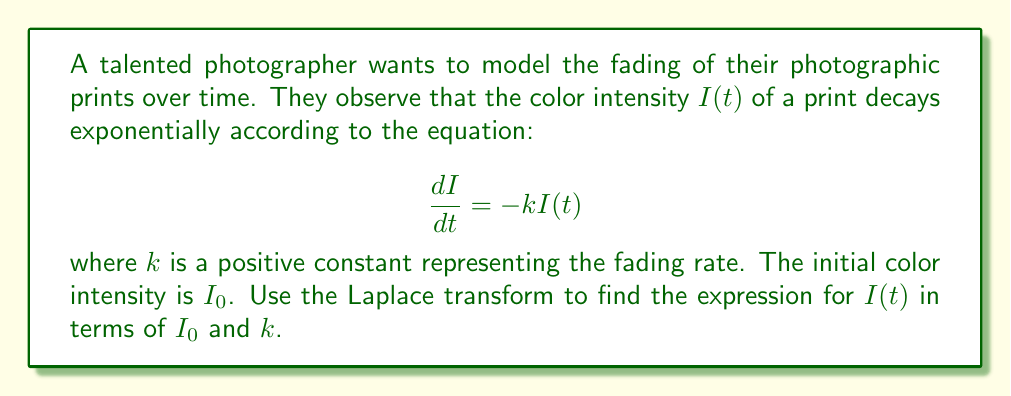Give your solution to this math problem. To solve this problem using Laplace transforms, we'll follow these steps:

1) First, let's take the Laplace transform of both sides of the differential equation:

   $$\mathcal{L}\left\{\frac{dI}{dt}\right\} = \mathcal{L}\{-kI(t)\}$$

2) Using the property of Laplace transform for derivatives:

   $$s\mathcal{L}\{I(t)\} - I(0) = -k\mathcal{L}\{I(t)\}$$

3) Let $\mathcal{L}\{I(t)\} = F(s)$. We know that $I(0) = I_0$. Substituting:

   $$sF(s) - I_0 = -kF(s)$$

4) Rearranging the equation:

   $$sF(s) + kF(s) = I_0$$
   $$(s + k)F(s) = I_0$$

5) Solving for $F(s)$:

   $$F(s) = \frac{I_0}{s + k}$$

6) This is the Laplace transform of $I(t)$. To find $I(t)$, we need to take the inverse Laplace transform:

   $$I(t) = \mathcal{L}^{-1}\left\{\frac{I_0}{s + k}\right\}$$

7) From the table of Laplace transforms, we recognize this as the transform of an exponential function:

   $$I(t) = I_0e^{-kt}$$

This is the final expression for the color intensity as a function of time.
Answer: $I(t) = I_0e^{-kt}$ 